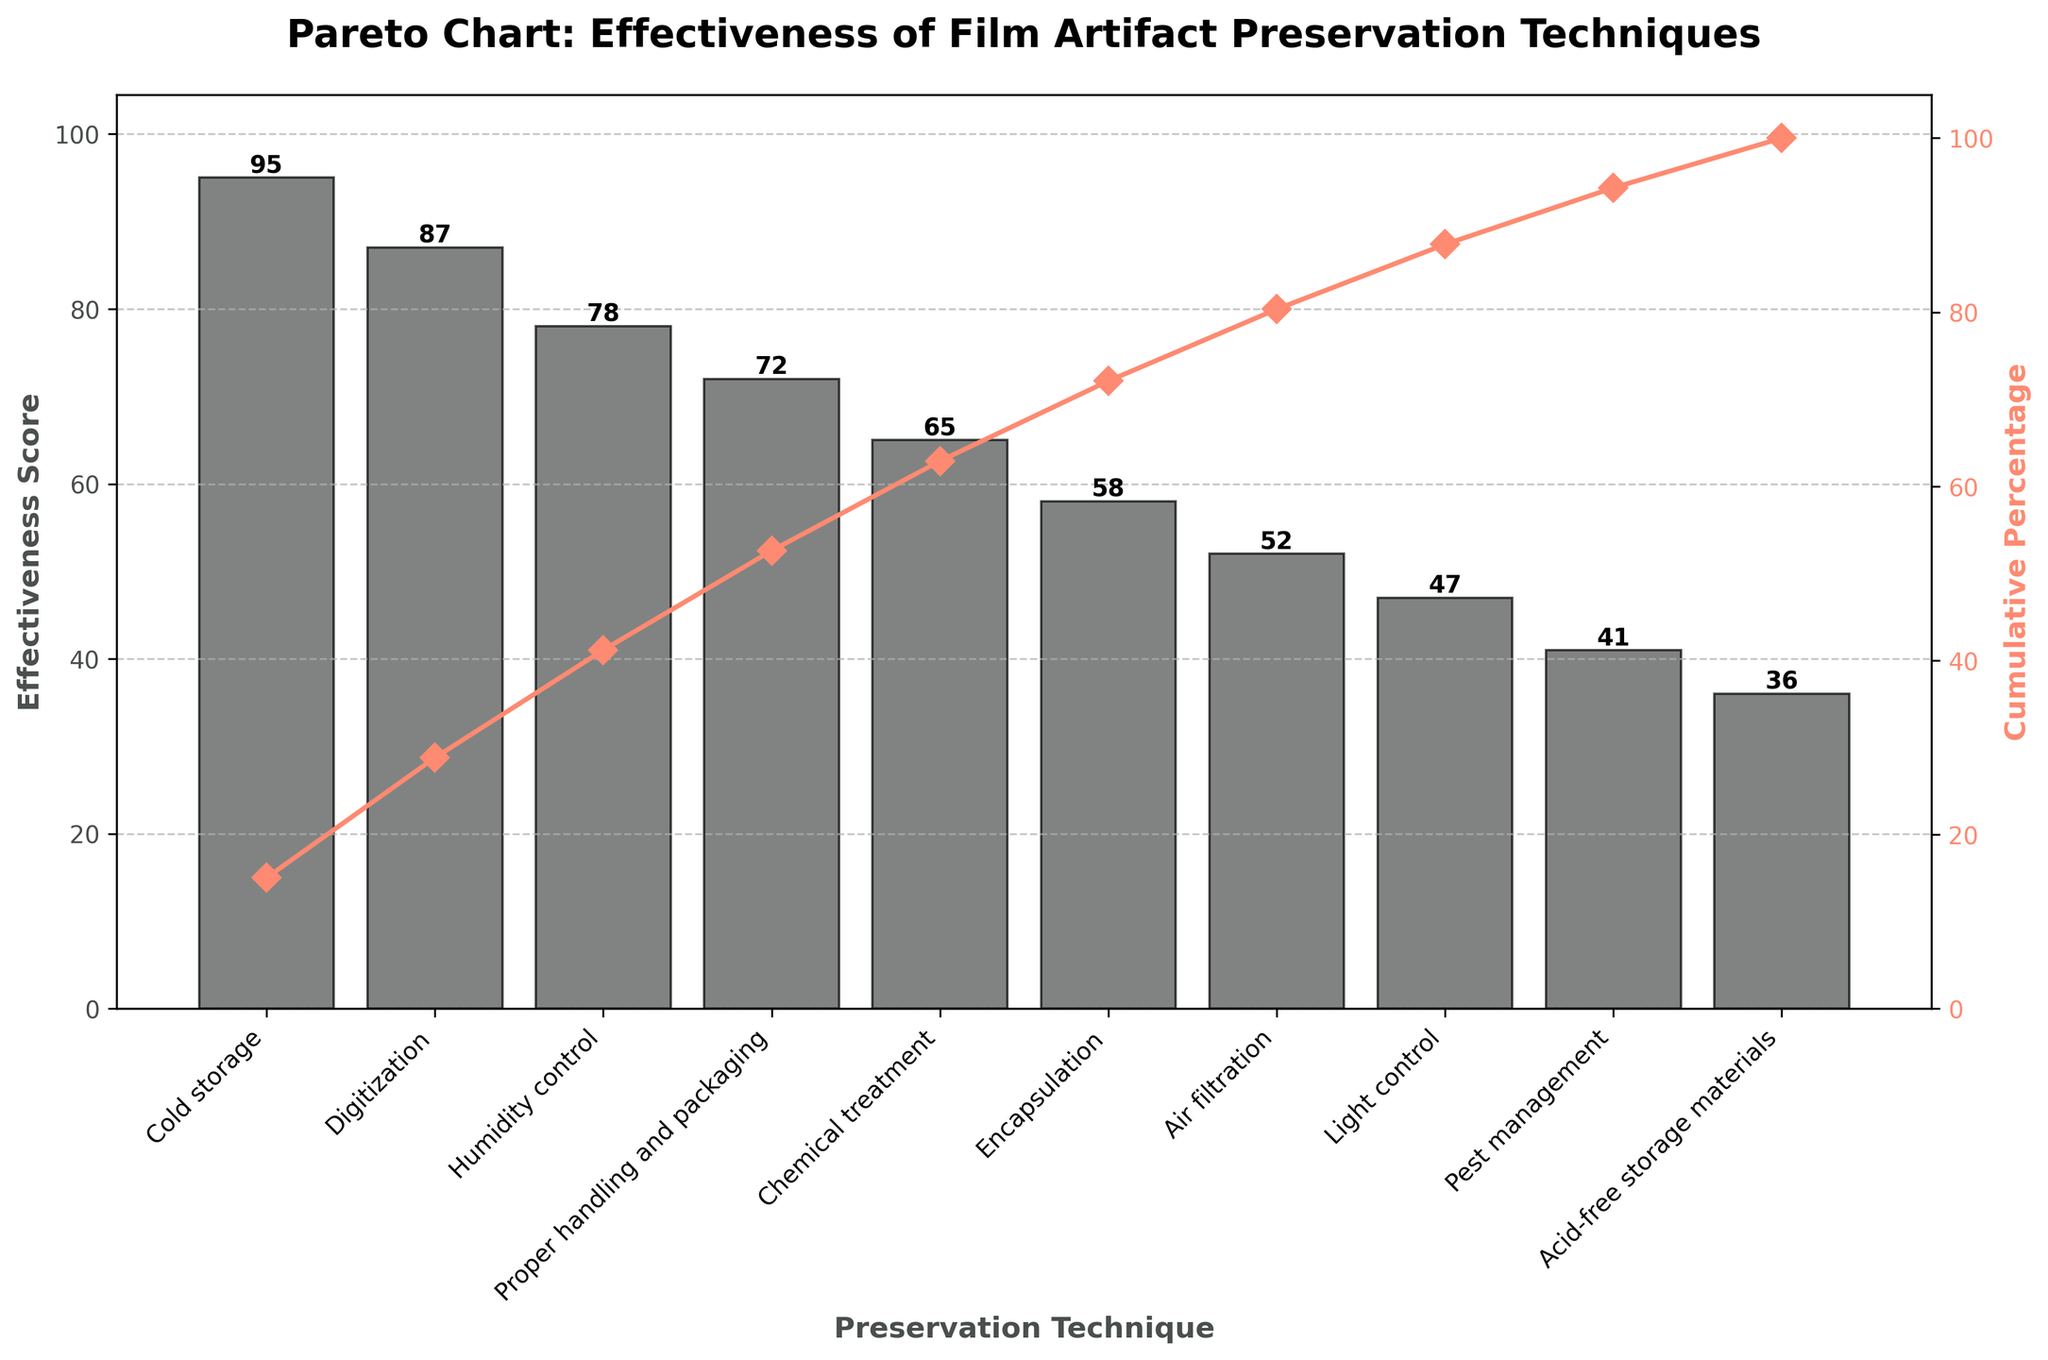What is the title of the figure? The title is usually placed at the top of the figure and provides a summary of the visualized information. In this case, it reads "Pareto Chart: Effectiveness of Film Artifact Preservation Techniques."
Answer: Pareto Chart: Effectiveness of Film Artifact Preservation Techniques What does the y-axis on the right represent? Pareto charts often have two y-axes. The right y-axis in this figure shows the cumulative percentage across all techniques, indicating how much each technique contributes to the total effectiveness score.
Answer: Cumulative Percentage Which technique has the highest effectiveness score? The highest bar in the chart represents the most effective technique. The label at the bottom of this bar is "Cold storage," and the corresponding score is 95.
Answer: Cold storage What is the cumulative percentage reached after 'Digitization'? To find this, locate the 'Digitization' bar and refer to the cumulative percentage line (in red) at the top of this bar, which falls at approximately 88%.
Answer: 88% Compare the effectiveness scores of 'Humidity control' and 'Chemical treatment.' Which one is higher? First, locate the bars for both 'Humidity control' and 'Chemical treatment'. The height of the 'Humidity control' bar is 78, while 'Chemical treatment' is 65. Therefore, 'Humidity control' has a higher effectiveness score.
Answer: Humidity control What is the median effectiveness score of all techniques listed? There are 10 techniques. To find the median, list the scores in order (36, 41, 47, 52, 58, 65, 72, 78, 87, 95). Since there are an even number of techniques, the median is the average of the 5th and 6th scores: (58 + 65) / 2 = 61.5.
Answer: 61.5 What is the total effectiveness score summed across all techniques? To get the total, sum all effectiveness scores: 95 + 87 + 78 + 72 + 65 + 58 + 52 + 47 + 41 + 36. This equals 631.
Answer: 631 What percentage of the total effectiveness is accounted for by the top three techniques? Sum the effectiveness scores of Cold storage, Digitization, and Humidity control: 95 + 87 + 78 = 260. The total effectiveness score is 631. Divide 260 by 631 and multiply by 100 to get the percentage: (260/631)*100 ≈ 41.2%.
Answer: 41.2% Which techniques contribute least to the cumulative effectiveness up to 50%? First, add the effectiveness scores until the cumulative total surpasses 50% of the overall effectiveness (315.5). The scores are 95 (15.1%), 87 (13.8%), 78 (12.4%), and 72 (11.4%), totaling 50%. Therefore, 'Proper handling and packaging' breaches the 50% mark, implying 'Cold storage,' 'Digitization,' 'Humidity control,' and 'Proper handling and packaging' contribute towards the first 50%.
Answer: Proper handling and packaging Which axis shows the Preservation Techniques? The techniques themselves are placed horizontally at the bottom of the chart, which is the x-axis. This axis labels each bar with a preservation technique name.
Answer: x-axis 